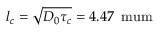Convert formula to latex. <formula><loc_0><loc_0><loc_500><loc_500>l _ { c } = \sqrt { D _ { 0 } \tau _ { c } } = 4 . 4 7 \, \ m u m</formula> 